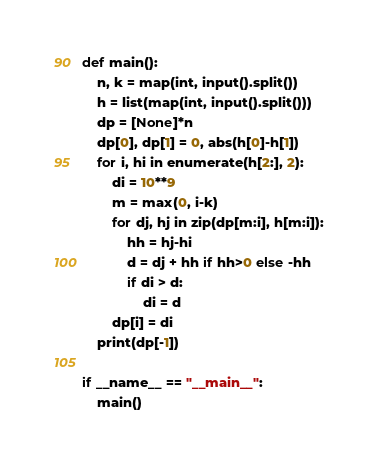Convert code to text. <code><loc_0><loc_0><loc_500><loc_500><_Python_>def main():
    n, k = map(int, input().split())
    h = list(map(int, input().split()))
    dp = [None]*n
    dp[0], dp[1] = 0, abs(h[0]-h[1])
    for i, hi in enumerate(h[2:], 2):
        di = 10**9
        m = max(0, i-k)
        for dj, hj in zip(dp[m:i], h[m:i]):
            hh = hj-hi
            d = dj + hh if hh>0 else -hh
            if di > d:
                di = d
        dp[i] = di
    print(dp[-1])

if __name__ == "__main__":
    main()</code> 